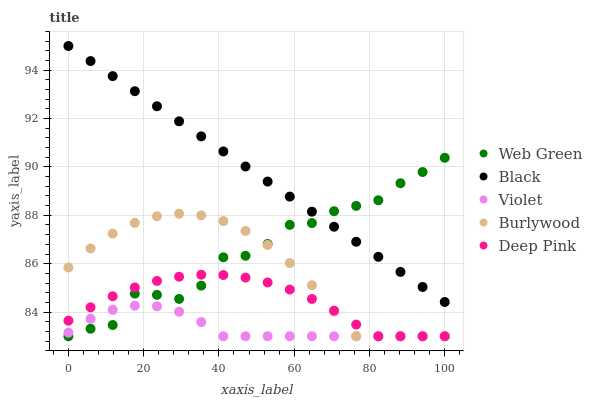Does Violet have the minimum area under the curve?
Answer yes or no. Yes. Does Black have the maximum area under the curve?
Answer yes or no. Yes. Does Deep Pink have the minimum area under the curve?
Answer yes or no. No. Does Deep Pink have the maximum area under the curve?
Answer yes or no. No. Is Black the smoothest?
Answer yes or no. Yes. Is Web Green the roughest?
Answer yes or no. Yes. Is Deep Pink the smoothest?
Answer yes or no. No. Is Deep Pink the roughest?
Answer yes or no. No. Does Burlywood have the lowest value?
Answer yes or no. Yes. Does Black have the lowest value?
Answer yes or no. No. Does Black have the highest value?
Answer yes or no. Yes. Does Deep Pink have the highest value?
Answer yes or no. No. Is Violet less than Black?
Answer yes or no. Yes. Is Black greater than Violet?
Answer yes or no. Yes. Does Violet intersect Web Green?
Answer yes or no. Yes. Is Violet less than Web Green?
Answer yes or no. No. Is Violet greater than Web Green?
Answer yes or no. No. Does Violet intersect Black?
Answer yes or no. No. 